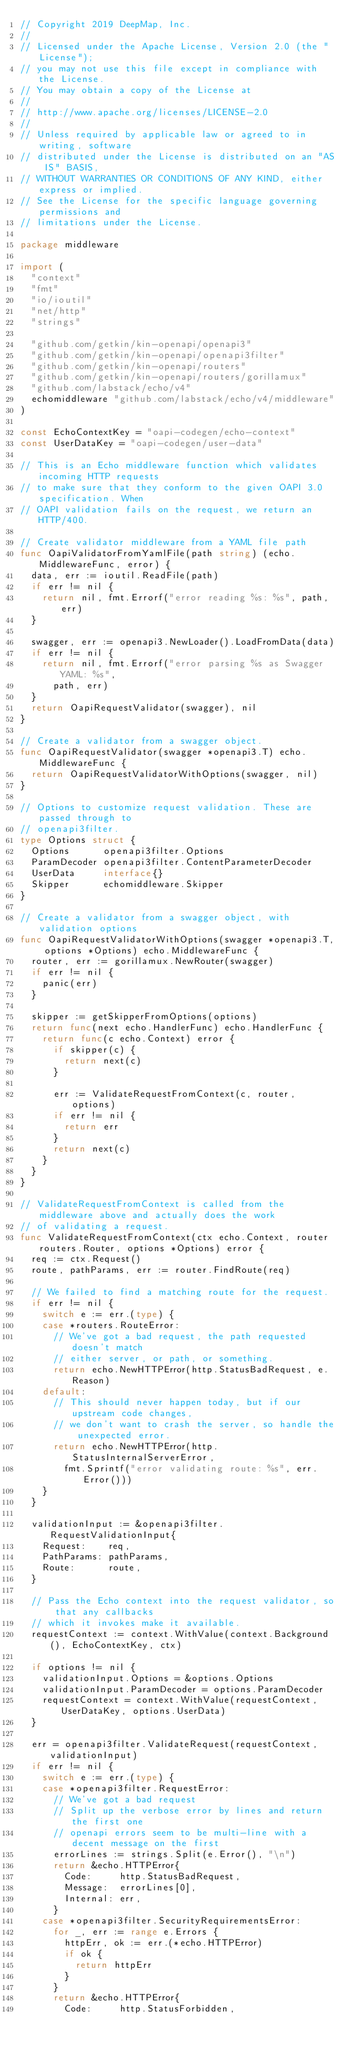Convert code to text. <code><loc_0><loc_0><loc_500><loc_500><_Go_>// Copyright 2019 DeepMap, Inc.
//
// Licensed under the Apache License, Version 2.0 (the "License");
// you may not use this file except in compliance with the License.
// You may obtain a copy of the License at
//
// http://www.apache.org/licenses/LICENSE-2.0
//
// Unless required by applicable law or agreed to in writing, software
// distributed under the License is distributed on an "AS IS" BASIS,
// WITHOUT WARRANTIES OR CONDITIONS OF ANY KIND, either express or implied.
// See the License for the specific language governing permissions and
// limitations under the License.

package middleware

import (
	"context"
	"fmt"
	"io/ioutil"
	"net/http"
	"strings"

	"github.com/getkin/kin-openapi/openapi3"
	"github.com/getkin/kin-openapi/openapi3filter"
	"github.com/getkin/kin-openapi/routers"
	"github.com/getkin/kin-openapi/routers/gorillamux"
	"github.com/labstack/echo/v4"
	echomiddleware "github.com/labstack/echo/v4/middleware"
)

const EchoContextKey = "oapi-codegen/echo-context"
const UserDataKey = "oapi-codegen/user-data"

// This is an Echo middleware function which validates incoming HTTP requests
// to make sure that they conform to the given OAPI 3.0 specification. When
// OAPI validation fails on the request, we return an HTTP/400.

// Create validator middleware from a YAML file path
func OapiValidatorFromYamlFile(path string) (echo.MiddlewareFunc, error) {
	data, err := ioutil.ReadFile(path)
	if err != nil {
		return nil, fmt.Errorf("error reading %s: %s", path, err)
	}

	swagger, err := openapi3.NewLoader().LoadFromData(data)
	if err != nil {
		return nil, fmt.Errorf("error parsing %s as Swagger YAML: %s",
			path, err)
	}
	return OapiRequestValidator(swagger), nil
}

// Create a validator from a swagger object.
func OapiRequestValidator(swagger *openapi3.T) echo.MiddlewareFunc {
	return OapiRequestValidatorWithOptions(swagger, nil)
}

// Options to customize request validation. These are passed through to
// openapi3filter.
type Options struct {
	Options      openapi3filter.Options
	ParamDecoder openapi3filter.ContentParameterDecoder
	UserData     interface{}
	Skipper      echomiddleware.Skipper
}

// Create a validator from a swagger object, with validation options
func OapiRequestValidatorWithOptions(swagger *openapi3.T, options *Options) echo.MiddlewareFunc {
	router, err := gorillamux.NewRouter(swagger)
	if err != nil {
		panic(err)
	}

	skipper := getSkipperFromOptions(options)
	return func(next echo.HandlerFunc) echo.HandlerFunc {
		return func(c echo.Context) error {
			if skipper(c) {
				return next(c)
			}

			err := ValidateRequestFromContext(c, router, options)
			if err != nil {
				return err
			}
			return next(c)
		}
	}
}

// ValidateRequestFromContext is called from the middleware above and actually does the work
// of validating a request.
func ValidateRequestFromContext(ctx echo.Context, router routers.Router, options *Options) error {
	req := ctx.Request()
	route, pathParams, err := router.FindRoute(req)

	// We failed to find a matching route for the request.
	if err != nil {
		switch e := err.(type) {
		case *routers.RouteError:
			// We've got a bad request, the path requested doesn't match
			// either server, or path, or something.
			return echo.NewHTTPError(http.StatusBadRequest, e.Reason)
		default:
			// This should never happen today, but if our upstream code changes,
			// we don't want to crash the server, so handle the unexpected error.
			return echo.NewHTTPError(http.StatusInternalServerError,
				fmt.Sprintf("error validating route: %s", err.Error()))
		}
	}

	validationInput := &openapi3filter.RequestValidationInput{
		Request:    req,
		PathParams: pathParams,
		Route:      route,
	}

	// Pass the Echo context into the request validator, so that any callbacks
	// which it invokes make it available.
	requestContext := context.WithValue(context.Background(), EchoContextKey, ctx)

	if options != nil {
		validationInput.Options = &options.Options
		validationInput.ParamDecoder = options.ParamDecoder
		requestContext = context.WithValue(requestContext, UserDataKey, options.UserData)
	}

	err = openapi3filter.ValidateRequest(requestContext, validationInput)
	if err != nil {
		switch e := err.(type) {
		case *openapi3filter.RequestError:
			// We've got a bad request
			// Split up the verbose error by lines and return the first one
			// openapi errors seem to be multi-line with a decent message on the first
			errorLines := strings.Split(e.Error(), "\n")
			return &echo.HTTPError{
				Code:     http.StatusBadRequest,
				Message:  errorLines[0],
				Internal: err,
			}
		case *openapi3filter.SecurityRequirementsError:
			for _, err := range e.Errors {
				httpErr, ok := err.(*echo.HTTPError)
				if ok {
					return httpErr
				}
			}
			return &echo.HTTPError{
				Code:     http.StatusForbidden,</code> 